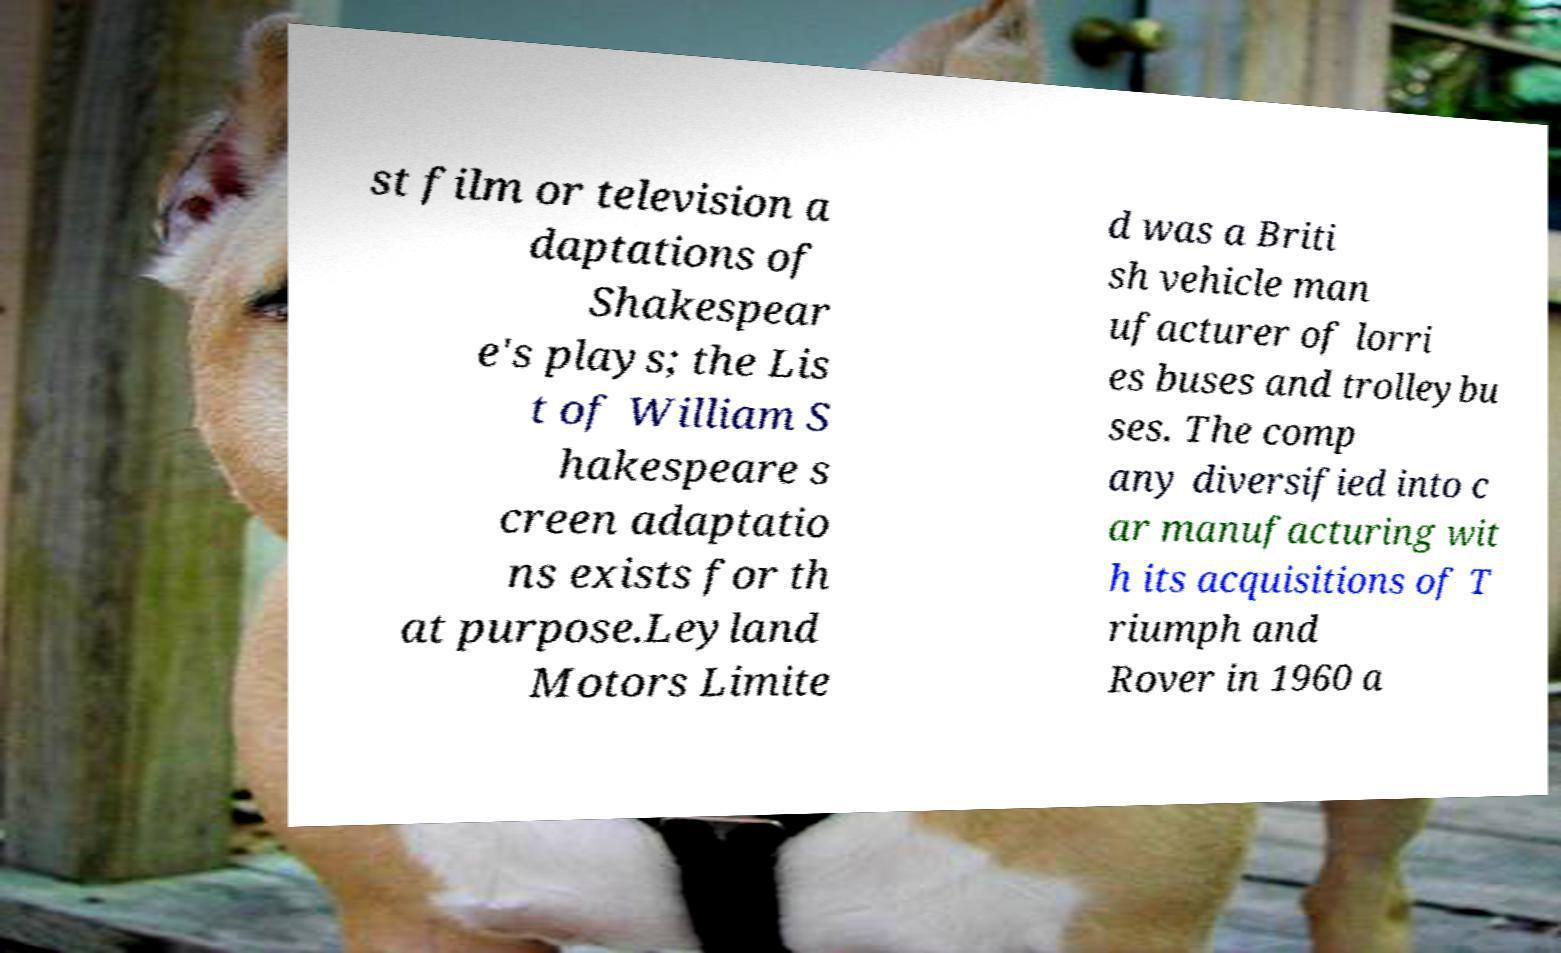I need the written content from this picture converted into text. Can you do that? st film or television a daptations of Shakespear e's plays; the Lis t of William S hakespeare s creen adaptatio ns exists for th at purpose.Leyland Motors Limite d was a Briti sh vehicle man ufacturer of lorri es buses and trolleybu ses. The comp any diversified into c ar manufacturing wit h its acquisitions of T riumph and Rover in 1960 a 